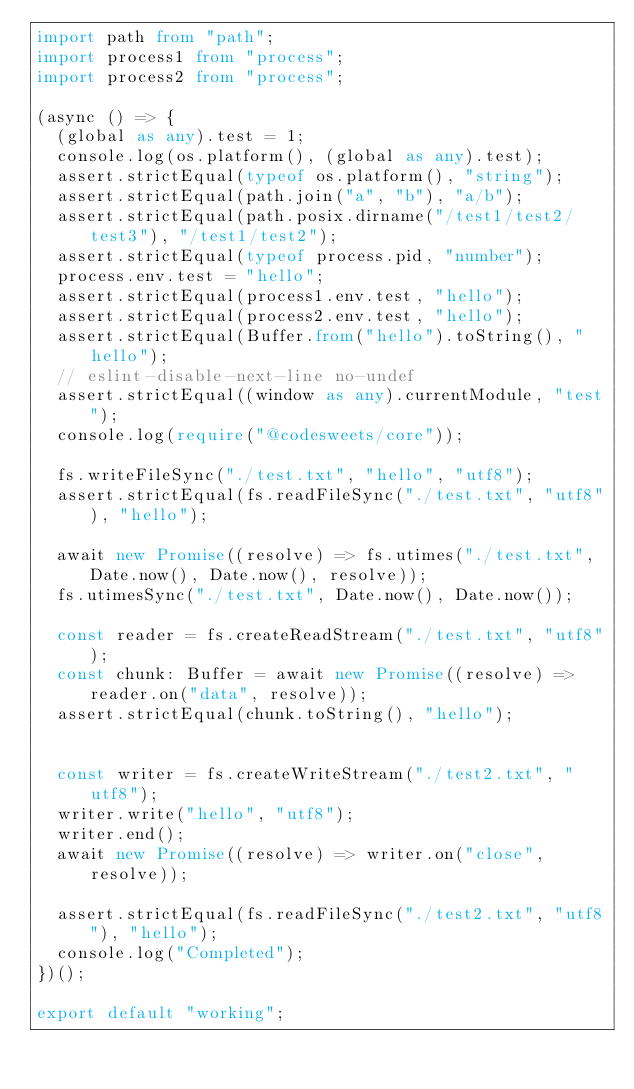<code> <loc_0><loc_0><loc_500><loc_500><_TypeScript_>import path from "path";
import process1 from "process";
import process2 from "process";

(async () => {
  (global as any).test = 1;
  console.log(os.platform(), (global as any).test);
  assert.strictEqual(typeof os.platform(), "string");
  assert.strictEqual(path.join("a", "b"), "a/b");
  assert.strictEqual(path.posix.dirname("/test1/test2/test3"), "/test1/test2");
  assert.strictEqual(typeof process.pid, "number");
  process.env.test = "hello";
  assert.strictEqual(process1.env.test, "hello");
  assert.strictEqual(process2.env.test, "hello");
  assert.strictEqual(Buffer.from("hello").toString(), "hello");
  // eslint-disable-next-line no-undef
  assert.strictEqual((window as any).currentModule, "test");
  console.log(require("@codesweets/core"));

  fs.writeFileSync("./test.txt", "hello", "utf8");
  assert.strictEqual(fs.readFileSync("./test.txt", "utf8"), "hello");

  await new Promise((resolve) => fs.utimes("./test.txt", Date.now(), Date.now(), resolve));
  fs.utimesSync("./test.txt", Date.now(), Date.now());

  const reader = fs.createReadStream("./test.txt", "utf8");
  const chunk: Buffer = await new Promise((resolve) => reader.on("data", resolve));
  assert.strictEqual(chunk.toString(), "hello");


  const writer = fs.createWriteStream("./test2.txt", "utf8");
  writer.write("hello", "utf8");
  writer.end();
  await new Promise((resolve) => writer.on("close", resolve));

  assert.strictEqual(fs.readFileSync("./test2.txt", "utf8"), "hello");
  console.log("Completed");
})();

export default "working";
</code> 